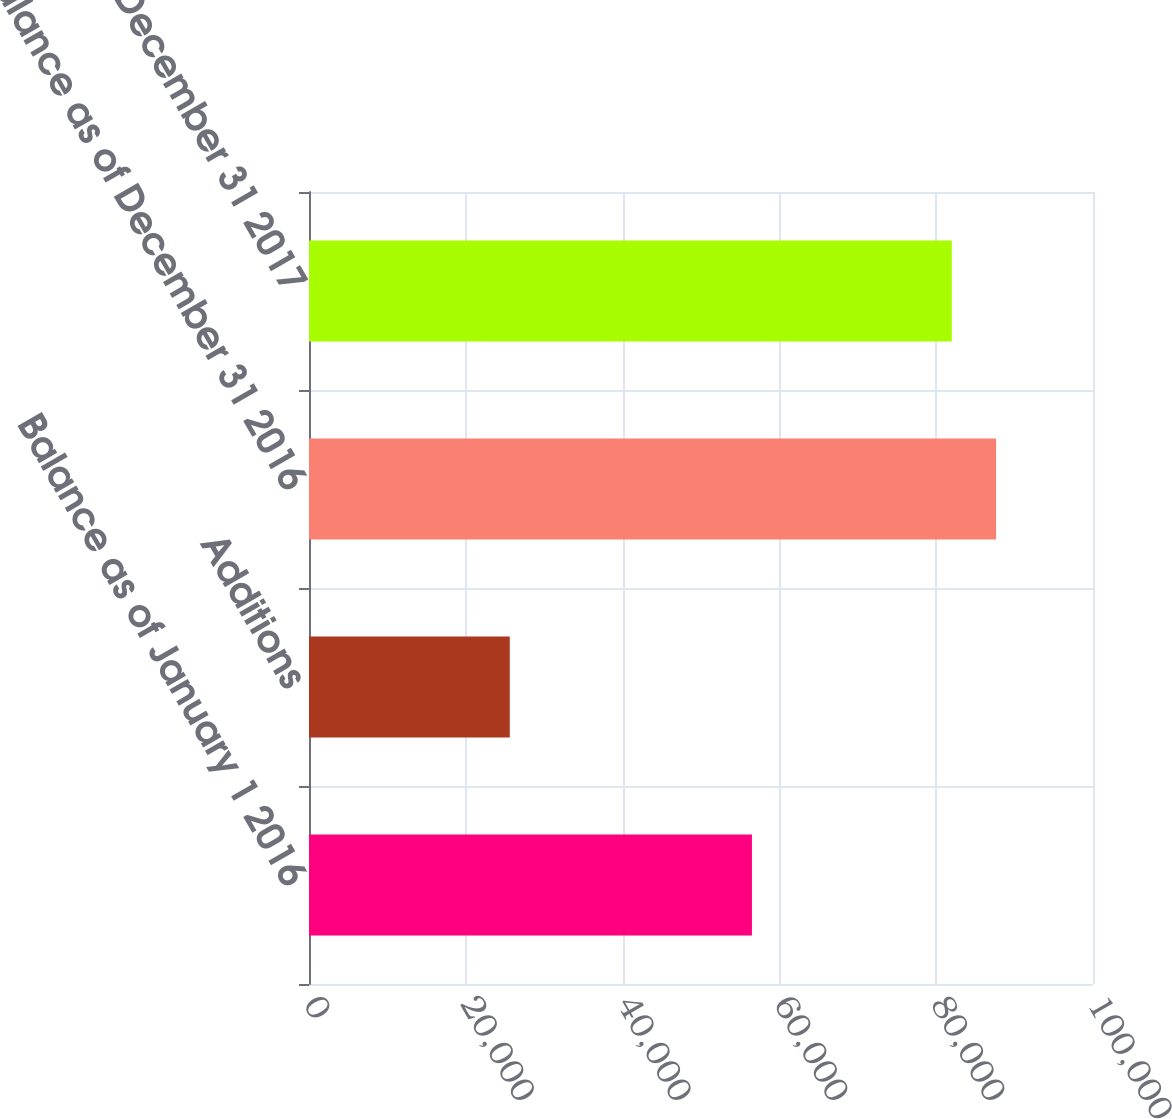<chart> <loc_0><loc_0><loc_500><loc_500><bar_chart><fcel>Balance as of January 1 2016<fcel>Additions<fcel>Balance as of December 31 2016<fcel>Balance as of December 31 2017<nl><fcel>56499<fcel>25609<fcel>87638.1<fcel>81989<nl></chart> 